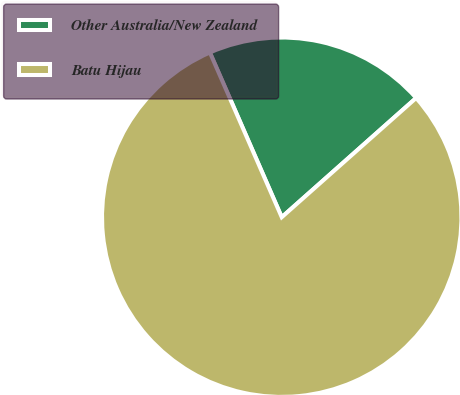Convert chart. <chart><loc_0><loc_0><loc_500><loc_500><pie_chart><fcel>Other Australia/New Zealand<fcel>Batu Hijau<nl><fcel>20.0%<fcel>80.0%<nl></chart> 